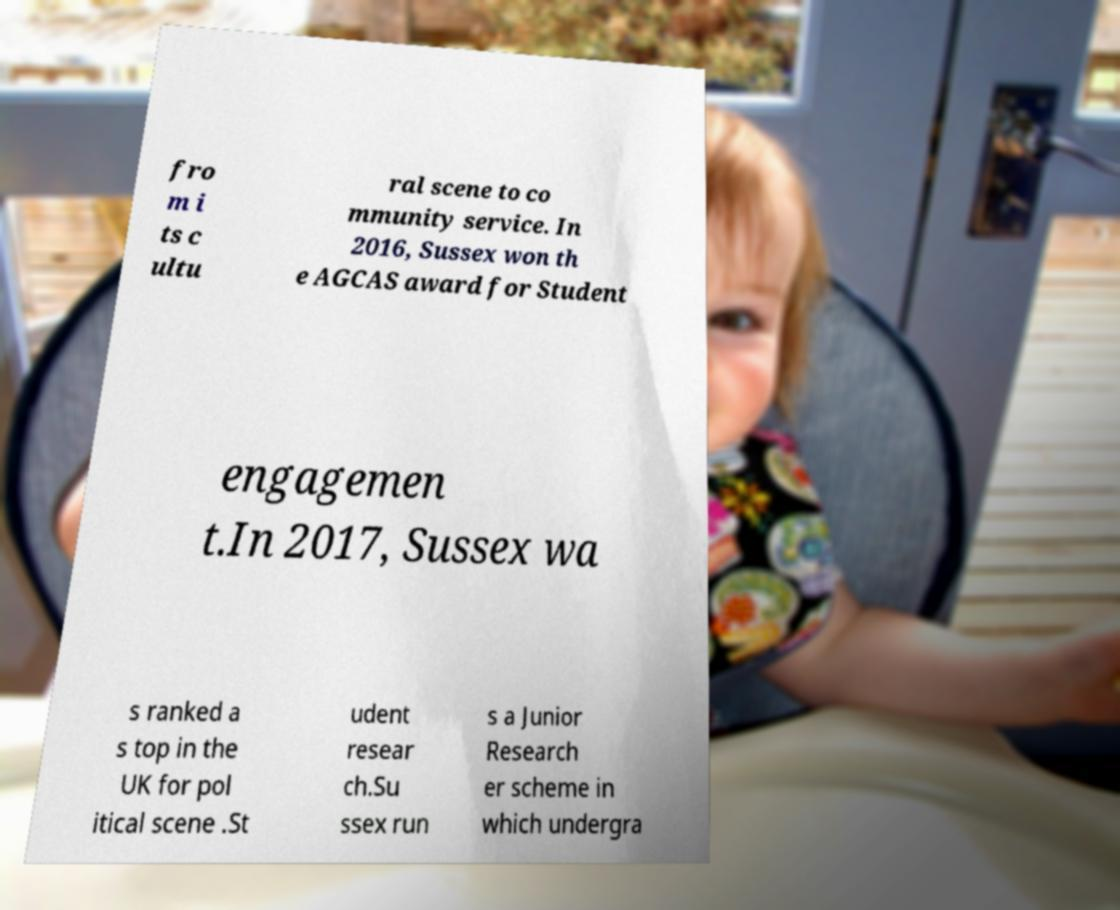For documentation purposes, I need the text within this image transcribed. Could you provide that? fro m i ts c ultu ral scene to co mmunity service. In 2016, Sussex won th e AGCAS award for Student engagemen t.In 2017, Sussex wa s ranked a s top in the UK for pol itical scene .St udent resear ch.Su ssex run s a Junior Research er scheme in which undergra 